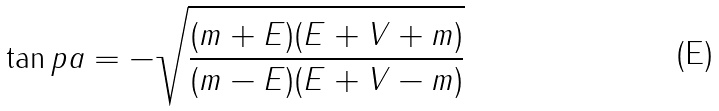<formula> <loc_0><loc_0><loc_500><loc_500>\tan p a = - \sqrt { \frac { ( m + E ) ( E + V + m ) } { ( m - E ) ( E + V - m ) } }</formula> 